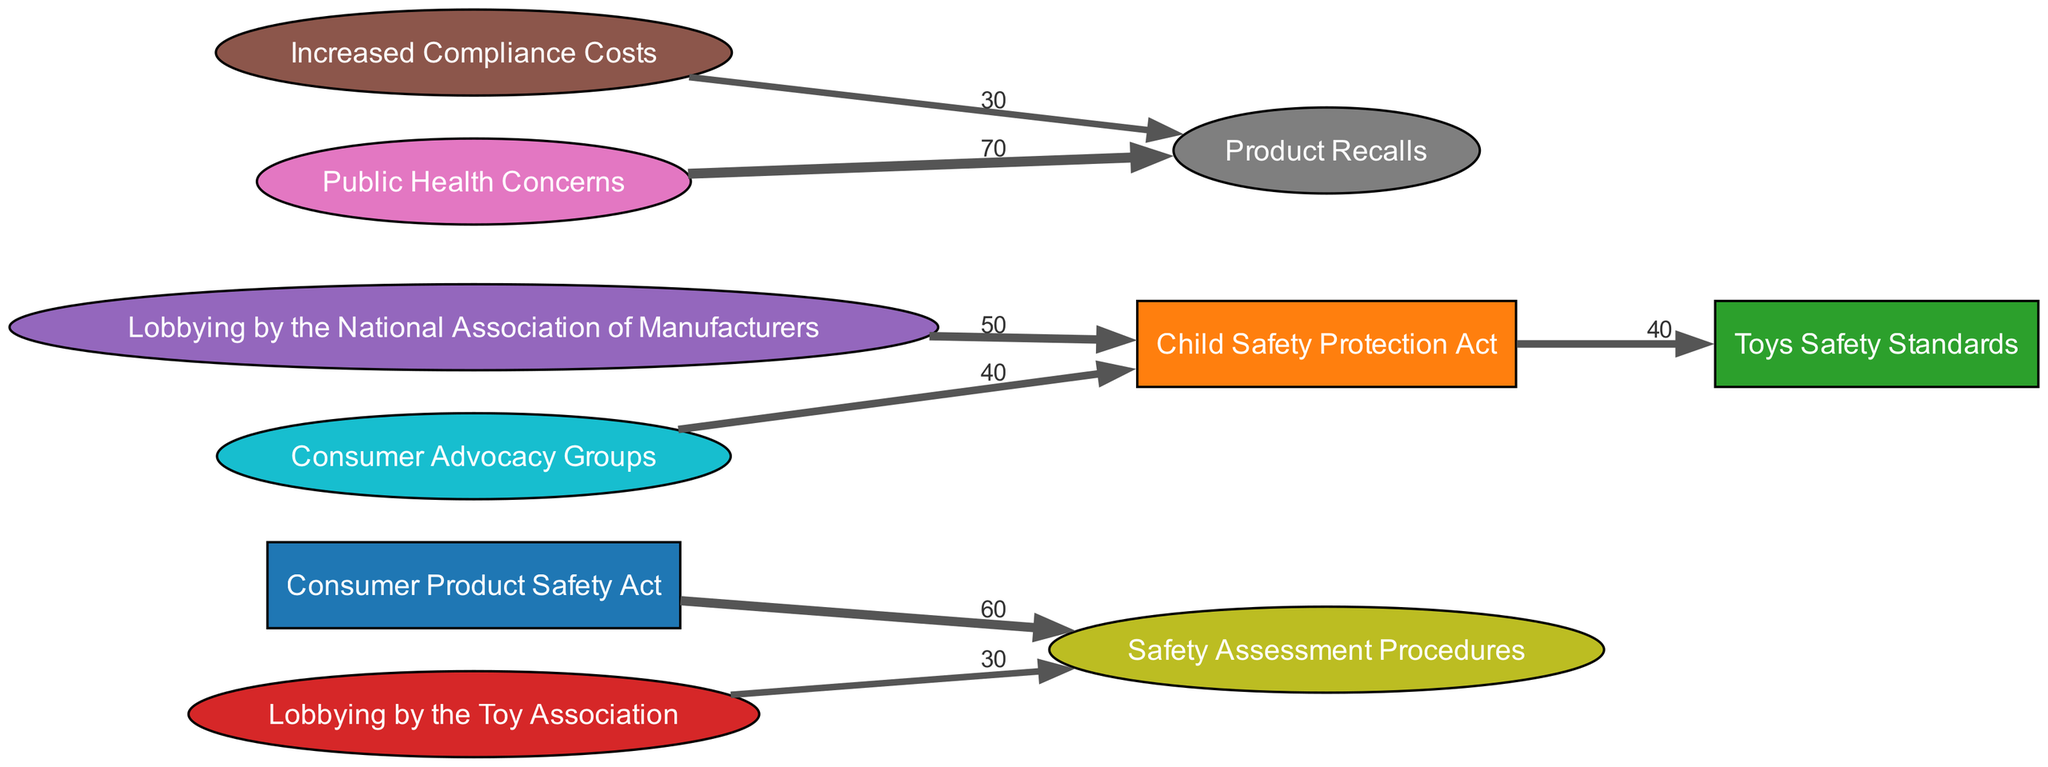What regulation change is linked to the Consumer Product Safety Act? The diagram shows a direct link from the Consumer Product Safety Act to Safety Assessment Procedures, indicating that this regulation change is influenced by it.
Answer: Safety Assessment Procedures How many lobbying efforts influence the Child Safety Protection Act? By examining the diagram, one can see that there are two lobbying efforts influencing the Child Safety Protection Act: Lobbying by the National Association of Manufacturers and Consumer Advocacy Groups.
Answer: 2 What is the value of lobbying by the Toy Association related to Safety Assessment Procedures? The diagram indicates a direct connection from Lobbying by the Toy Association to Safety Assessment Procedures with a specified value of 30.
Answer: 30 Which outcome is influenced by public health concerns? The diagram reveals that Public Health Concerns have a direct link to Product Recalls, showing that this particular outcome is influenced by those concerns.
Answer: Product Recalls What is the sum total of lobbying values influencing the Toys Safety Standards? By summarizing the values from direct connections to the Toys Safety Standards, we find that the total value is 40, coming only from the Child Safety Protection Act.
Answer: 40 Which impact is associated with both increased compliance costs and public health concerns? The diagram shows that both Increased Compliance Costs and Public Health Concerns have an impact on the same outcome, which is Product Recalls.
Answer: Product Recalls How does lobbying by the National Association of Manufacturers relate to changes in safety regulations? The diagram indicates that lobbying by the National Association of Manufacturers directly connects to the Child Safety Protection Act, suggesting their influence on this regulation.
Answer: Child Safety Protection Act What type of diagram is being used to visualize the flow of regulation changes and lobbying efforts? This is a Sankey Diagram, which is designed to represent the flow of values between different nodes, highlighting the relationships and impacts between regulations and lobbying efforts.
Answer: Sankey Diagram 